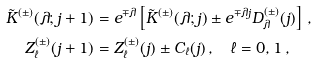Convert formula to latex. <formula><loc_0><loc_0><loc_500><loc_500>\tilde { K } ^ { ( \pm ) } ( \lambda ; j + 1 ) & = e ^ { \mp \lambda } \left [ \tilde { K } ^ { ( \pm ) } ( \lambda ; j ) \pm e ^ { \mp \lambda j } D ^ { ( \pm ) } _ { \lambda } ( j ) \right ] \, , \\ Z _ { \ell } ^ { ( \pm ) } ( j + 1 ) & = Z _ { \ell } ^ { ( \pm ) } ( j ) \pm C _ { \ell } ( j ) \, , \quad \ell = 0 , 1 \, ,</formula> 